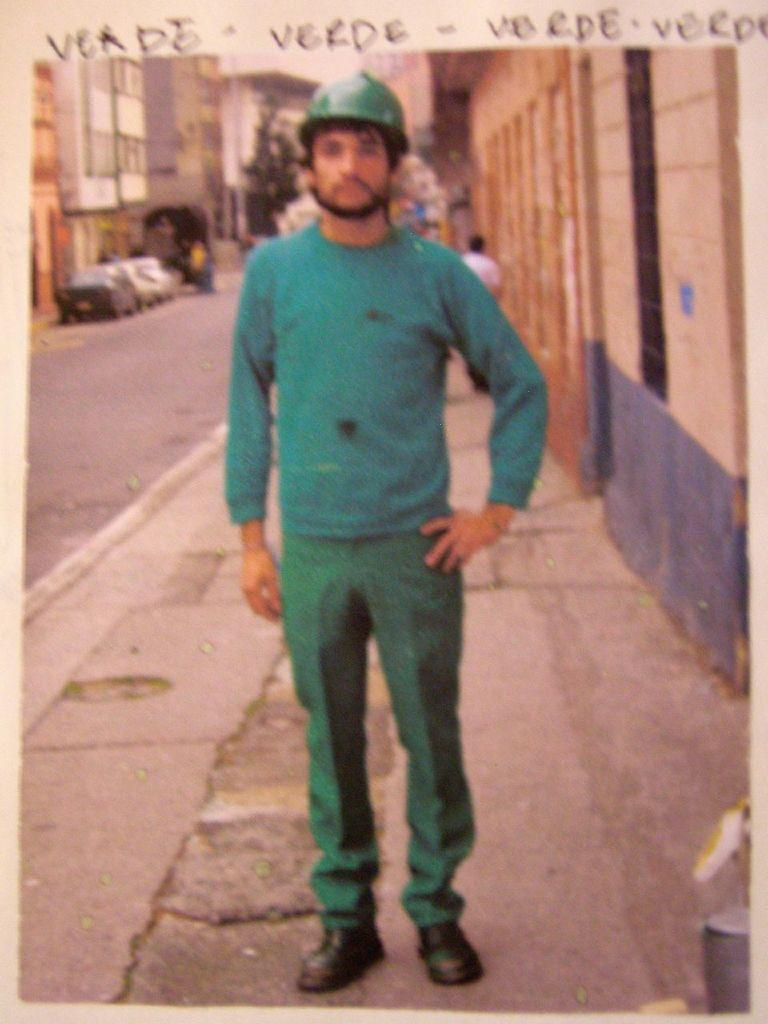What is the man in the image doing? The man is standing on the footpath in the image. What is the man wearing on his head? The man is wearing a helmet. What can be seen in the background of the image? There are buildings in the background. What is present on the road in the image? There are vehicles on the road. What type of trail can be seen on the man's ear in the image? There is no trail visible on the man's ear in the image. 